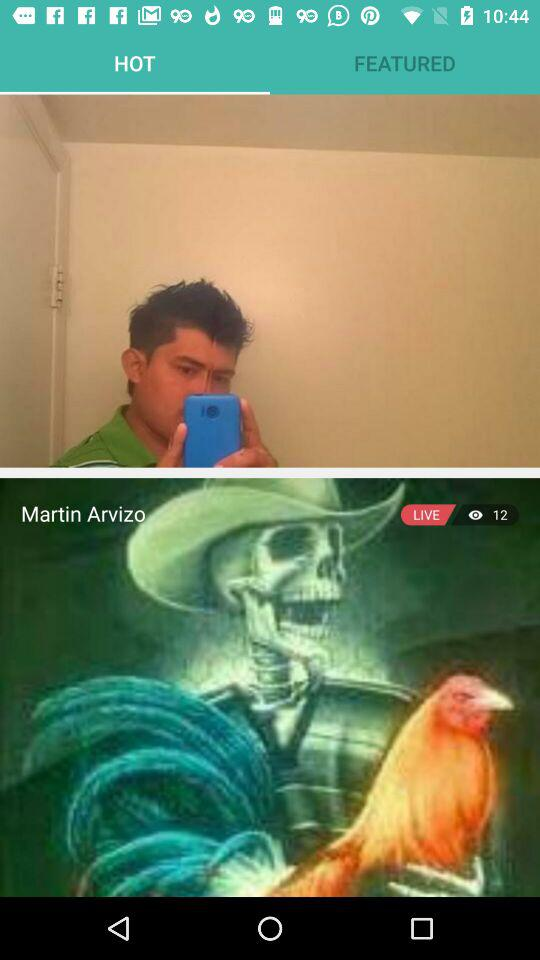Which tab is selected? The selected tab is "HOT". 